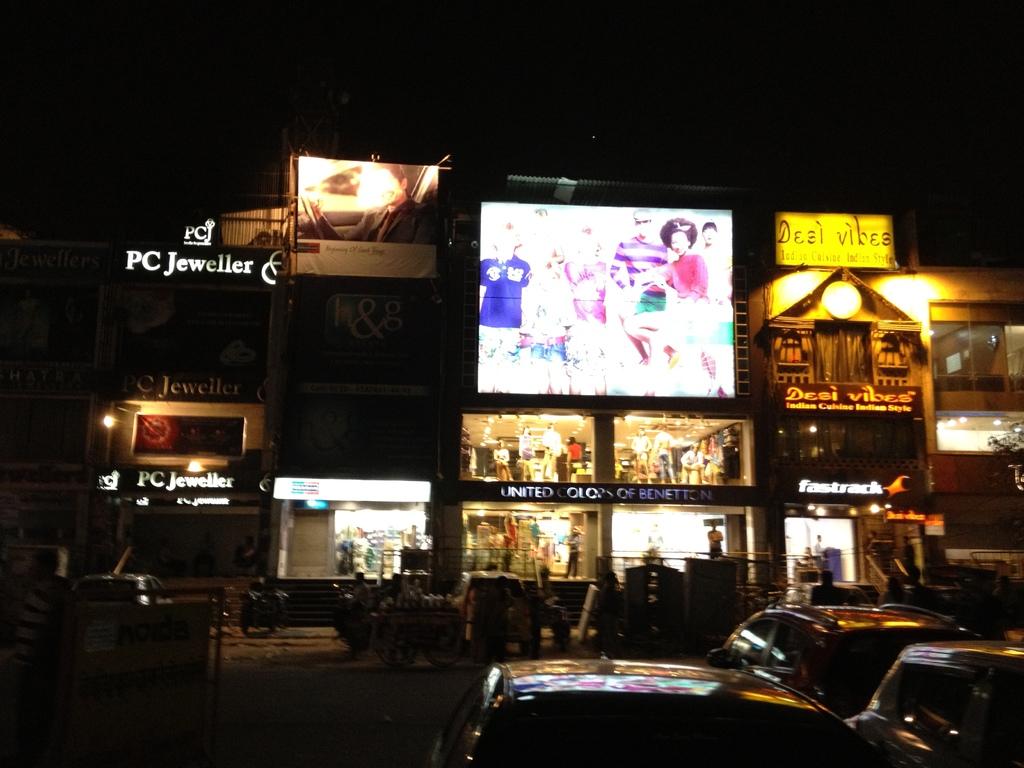What jeweller is being advertised?
Offer a very short reply. Pc jeweller. What is the name of this store?
Keep it short and to the point. Pc jeweller. 